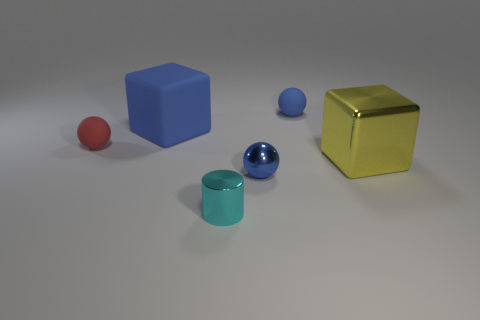What color is the small matte sphere in front of the tiny blue object behind the yellow block that is behind the small blue metal sphere?
Give a very brief answer. Red. Is the shape of the blue metal object the same as the large thing behind the large yellow shiny object?
Keep it short and to the point. No. There is a tiny object that is both behind the cyan metal cylinder and left of the tiny metallic ball; what color is it?
Make the answer very short. Red. Is there a tiny shiny object that has the same shape as the large matte thing?
Make the answer very short. No. Is the color of the metallic ball the same as the small cylinder?
Provide a short and direct response. No. There is a large cube that is in front of the tiny red object; are there any large shiny things that are to the left of it?
Provide a succinct answer. No. How many things are either spheres in front of the large blue matte block or tiny balls that are behind the metallic sphere?
Your answer should be very brief. 3. How many objects are large blue matte things or large cubes on the left side of the yellow thing?
Offer a very short reply. 1. What size is the blue ball in front of the ball that is to the left of the large thing on the left side of the metal block?
Your answer should be compact. Small. There is a cyan object that is the same size as the red object; what material is it?
Make the answer very short. Metal. 